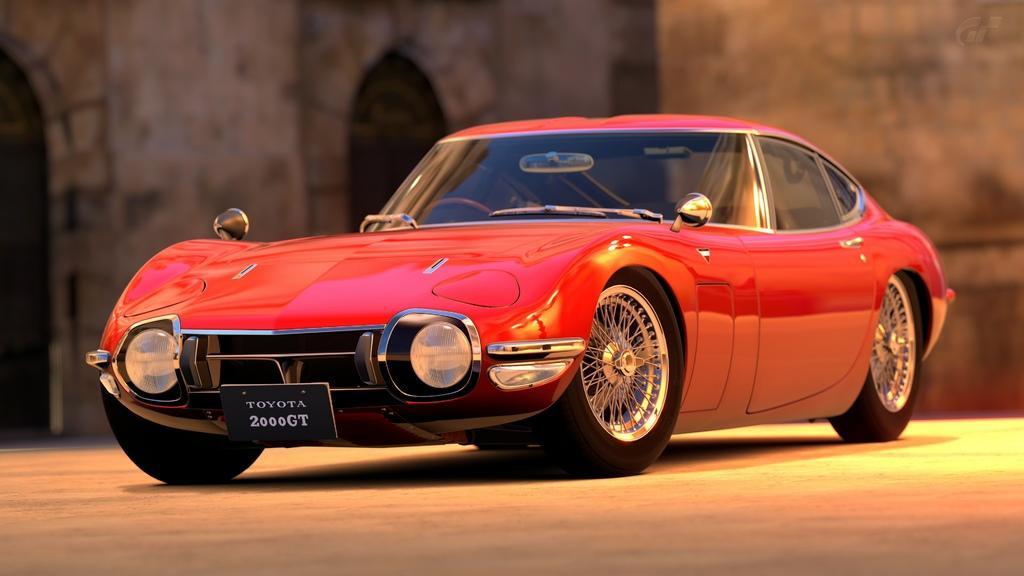How would you summarize this image in a sentence or two? In the picture I can see a red color car on the ground. The background of the image is blurred. 